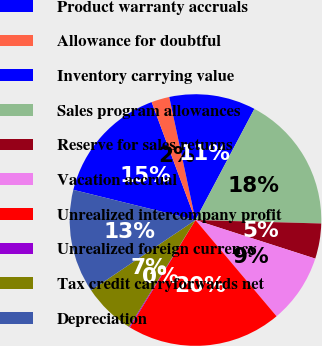Convert chart. <chart><loc_0><loc_0><loc_500><loc_500><pie_chart><fcel>Product warranty accruals<fcel>Allowance for doubtful<fcel>Inventory carrying value<fcel>Sales program allowances<fcel>Reserve for sales returns<fcel>Vacation accrual<fcel>Unrealized intercompany profit<fcel>Unrealized foreign currency<fcel>Tax credit carryforwards net<fcel>Depreciation<nl><fcel>15.48%<fcel>2.32%<fcel>11.1%<fcel>17.68%<fcel>4.52%<fcel>8.9%<fcel>19.87%<fcel>0.13%<fcel>6.71%<fcel>13.29%<nl></chart> 